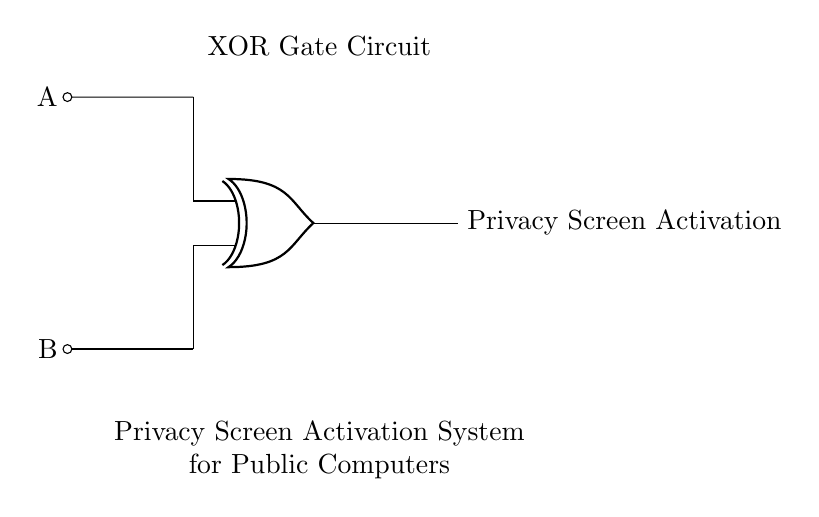What are the inputs to the XOR gate? The inputs to the XOR gate in the circuit are labeled A and B, which are represented by the lines entering the gate from the left.
Answer: A and B What does the output of the XOR gate signify? The output of the XOR gate indicates whether the privacy screen should be activated. It produces a true output when exactly one of the inputs (A or B) is true, reflecting the need for activation when there is a condition change.
Answer: Privacy Screen Activation How many inputs does the XOR gate have? An XOR gate has two inputs. In this circuit, these inputs are A and B, which are required for the gate's operation.
Answer: 2 What type of gate is this circuit using? This circuit is using an XOR gate, which is indicated in the diagram by the specific symbol labeled as 'xor port'.
Answer: XOR gate What condition must be met for the privacy screen to be activated? For the privacy screen to be activated, one and only one of the inputs (A or B) must be true; this is the defining behavior of an XOR operation.
Answer: One input must be true What is the purpose of the privacy screen in this system? The purpose of the privacy screen is to protect user information on public computers; it activates under specific conditions defined by the XOR gate's functionality.
Answer: To protect user information What does the label 'XOR Gate Circuit' describe? The label describes the type of logic gate used in the circuit, which processes the inputs A and B to determine whether the output should be triggered for activating the privacy screen.
Answer: The type of logic gate used 